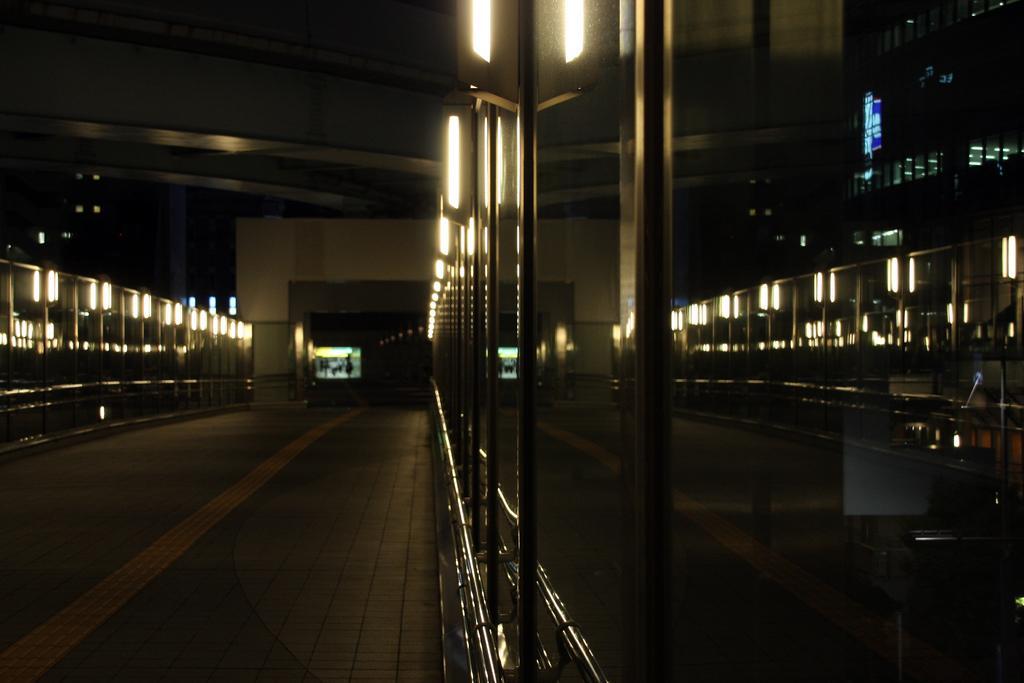In one or two sentences, can you explain what this image depicts? In this picture we can observe floor. On the right side there are glass doors and lights. We can observe a wall in the background. On the left side it is completely dark in the background. 